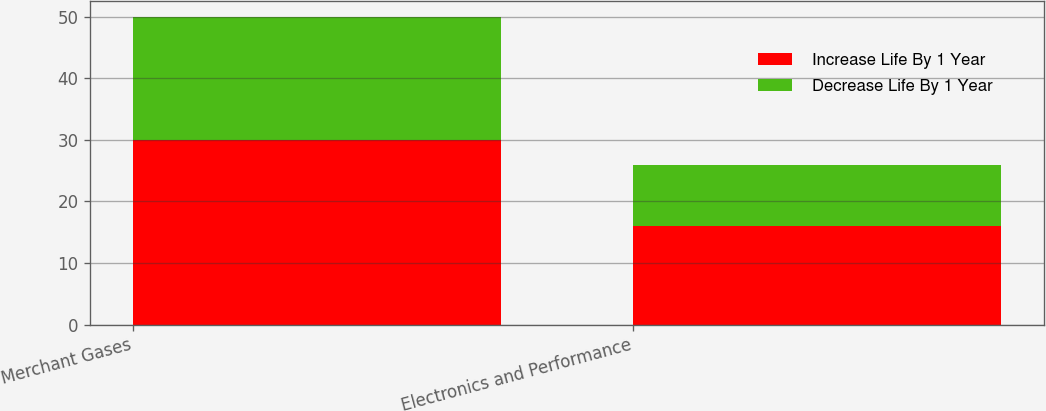Convert chart to OTSL. <chart><loc_0><loc_0><loc_500><loc_500><stacked_bar_chart><ecel><fcel>Merchant Gases<fcel>Electronics and Performance<nl><fcel>Increase Life By 1 Year<fcel>30<fcel>16<nl><fcel>Decrease Life By 1 Year<fcel>20<fcel>10<nl></chart> 